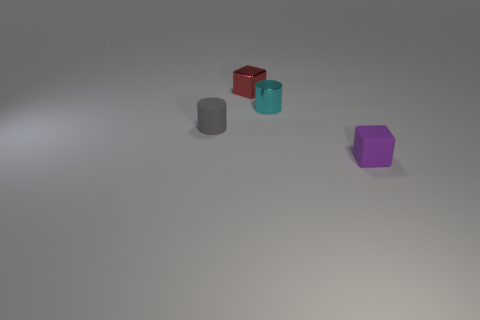There is a small object that is both behind the gray matte thing and in front of the small red shiny cube; what is its shape?
Your response must be concise. Cylinder. Are there the same number of tiny red metallic cubes that are right of the red metal cube and purple blocks right of the purple object?
Your answer should be very brief. Yes. There is a object that is in front of the tiny gray matte cylinder; is it the same shape as the small red metal thing?
Give a very brief answer. Yes. What number of gray objects are either metal cubes or blocks?
Make the answer very short. 0. There is another object that is the same shape as the purple matte object; what is it made of?
Your answer should be compact. Metal. What is the shape of the small thing that is behind the cyan metallic cylinder?
Your answer should be compact. Cube. Are there any small cyan objects made of the same material as the tiny purple object?
Make the answer very short. No. Is the gray rubber cylinder the same size as the matte cube?
Keep it short and to the point. Yes. How many cylinders are tiny objects or red objects?
Your answer should be very brief. 2. What number of small purple rubber objects have the same shape as the small red metal thing?
Provide a succinct answer. 1. 